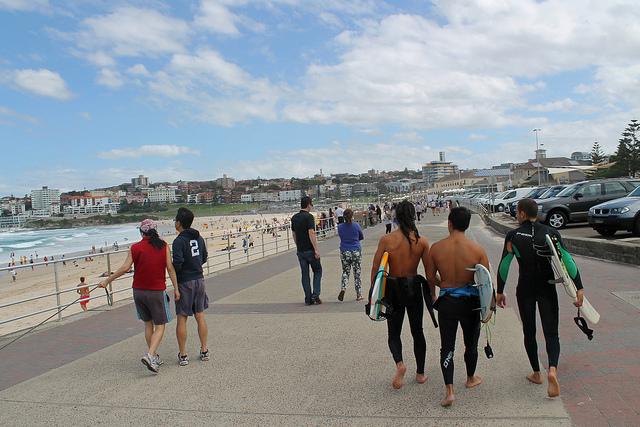Are the people at the beach?
Concise answer only. Yes. How many people are not wearing shirts?
Give a very brief answer. 2. Is the day cold?
Quick response, please. No. Is this a parade?
Give a very brief answer. No. What sport is this?
Short answer required. Surfing. What is the man holding?
Answer briefly. Surfboard. What are these people walking on?
Short answer required. Pavement. How many surfers are walking on the sidewalk?
Answer briefly. 3. 